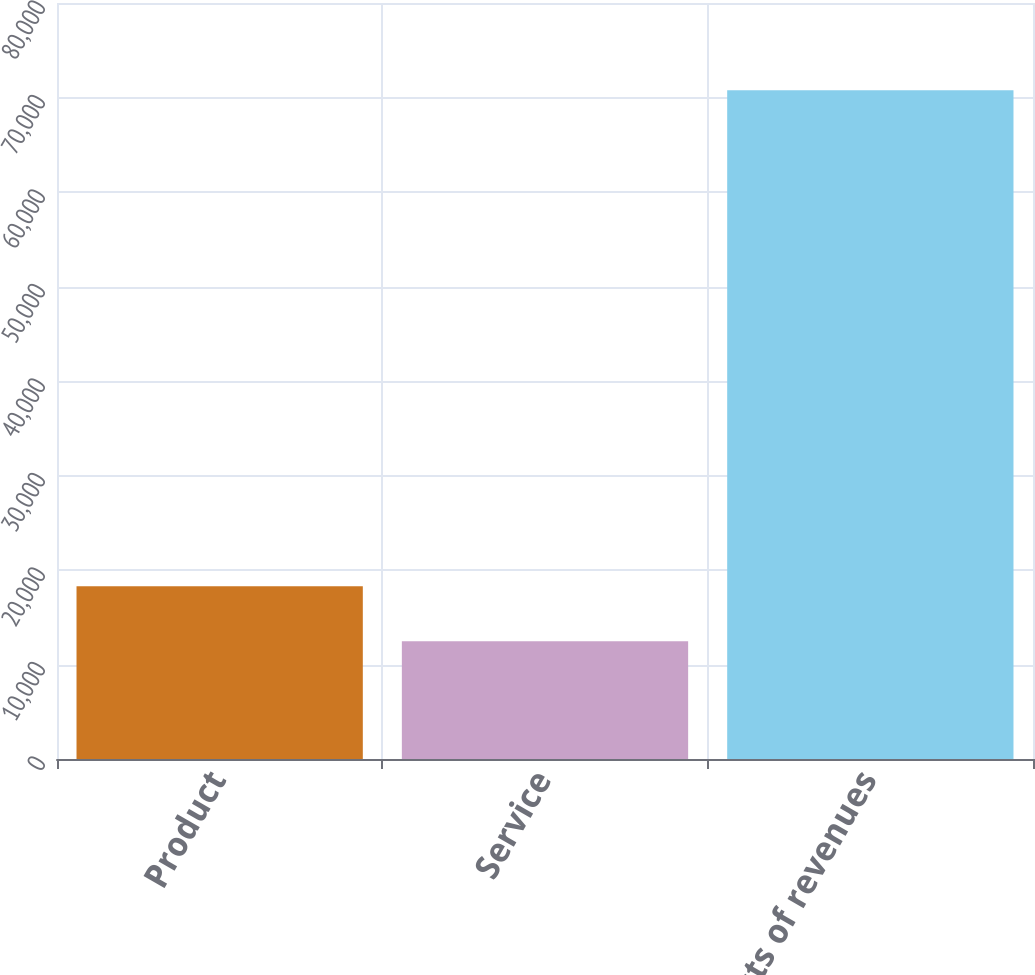<chart> <loc_0><loc_0><loc_500><loc_500><bar_chart><fcel>Product<fcel>Service<fcel>Costs of revenues<nl><fcel>18291.3<fcel>12460<fcel>70773<nl></chart> 